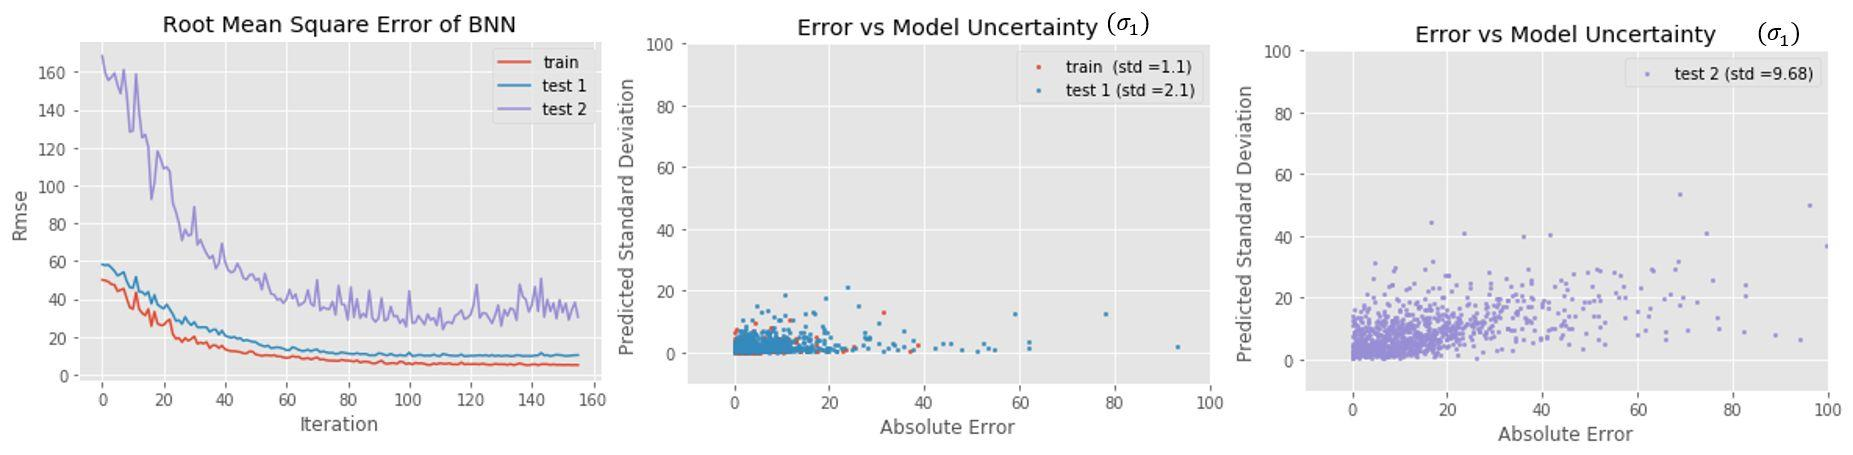How does the model uncertainty for 'test 2' compare to 'test 1' as shown in the figures? A. 'Test 2' has lower model uncertainty than 'test 1'. B. 'Test 2' has higher model uncertainty than 'test 1'. C. 'Test 2' and 'test 1' have the same level of model uncertainty. D. It's not possible to compare the model uncertainty between 'test 2' and 'test 1'. The legend of Figure 3 indicates a standard deviation of 9.68 for 'test 2', which is significantly higher than the standard deviation for 'test 1' (std = 2.1) in Figure 2, indicating higher model uncertainty for 'test 2'. Therefore, the correct answer is B. 